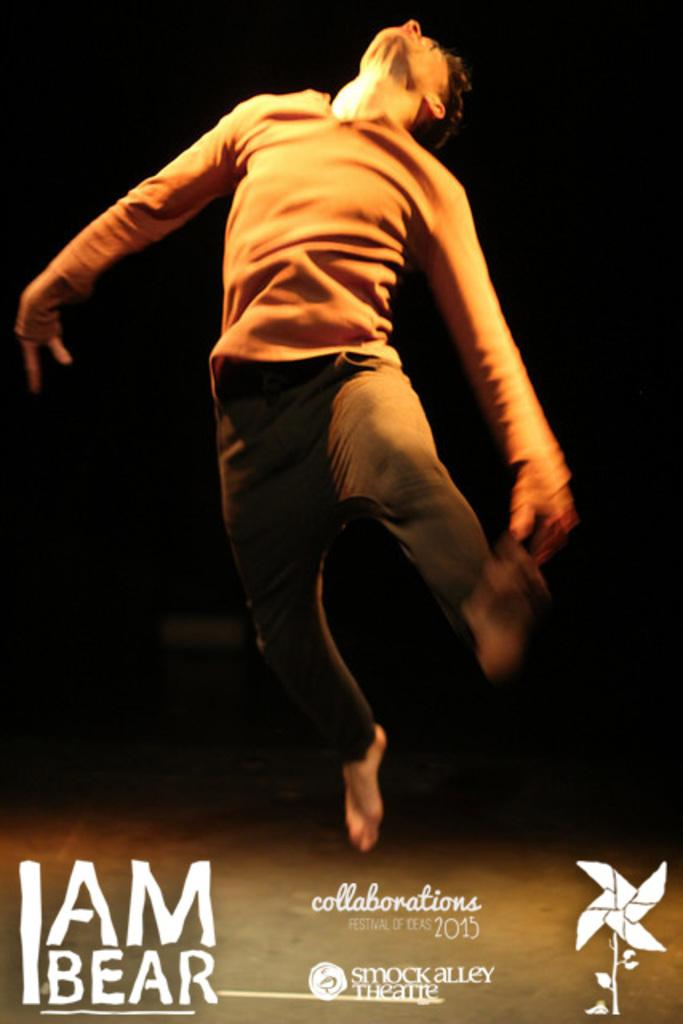What is happening with the person in the image? The person is in the air with a pose in the image. Can you describe any additional details about the person or their pose? Unfortunately, the provided facts do not offer any further details about the person or their pose. What is written at the bottom of the image? There is some text at the bottom of the image. What type of drum is the man playing in the image? There is no man or drum present in the image. How many lettuce leaves are visible in the image? There is no lettuce present in the image. 